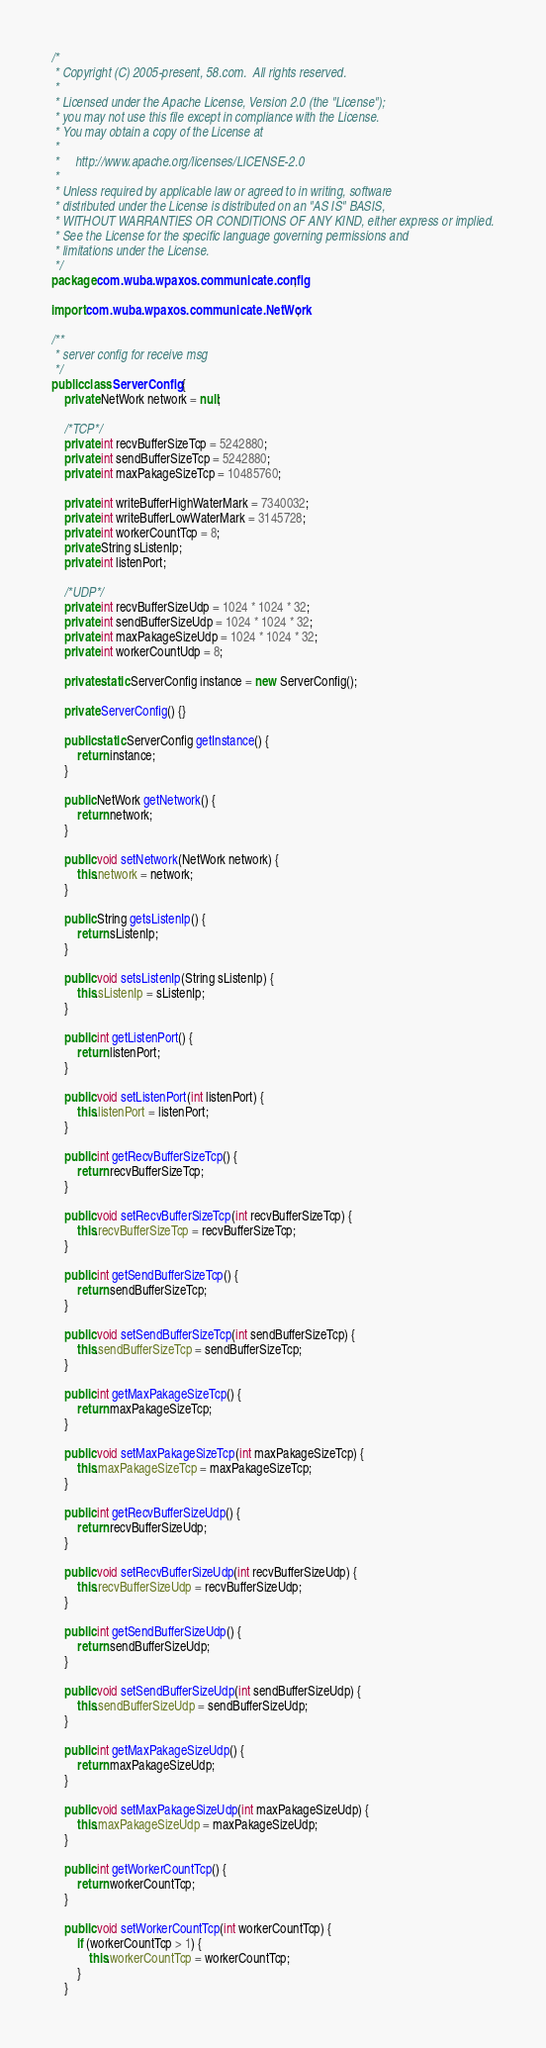Convert code to text. <code><loc_0><loc_0><loc_500><loc_500><_Java_>/*
 * Copyright (C) 2005-present, 58.com.  All rights reserved.
 * 
 * Licensed under the Apache License, Version 2.0 (the "License");
 * you may not use this file except in compliance with the License.
 * You may obtain a copy of the License at
 *
 *     http://www.apache.org/licenses/LICENSE-2.0
 *
 * Unless required by applicable law or agreed to in writing, software
 * distributed under the License is distributed on an "AS IS" BASIS,
 * WITHOUT WARRANTIES OR CONDITIONS OF ANY KIND, either express or implied.
 * See the License for the specific language governing permissions and
 * limitations under the License.
 */
package com.wuba.wpaxos.communicate.config;

import com.wuba.wpaxos.communicate.NetWork;

/**
 * server config for receive msg
 */
public class ServerConfig {
	private NetWork network = null;
	
	/*TCP*/
	private int recvBufferSizeTcp = 5242880;
	private int sendBufferSizeTcp = 5242880;
	private int maxPakageSizeTcp = 10485760;

	private int writeBufferHighWaterMark = 7340032;
	private int writeBufferLowWaterMark = 3145728;
	private int workerCountTcp = 8; 
	private String sListenIp;
	private int listenPort;
	
	/*UDP*/
	private int recvBufferSizeUdp = 1024 * 1024 * 32;
	private int sendBufferSizeUdp = 1024 * 1024 * 32;
	private int maxPakageSizeUdp = 1024 * 1024 * 32;
	private int workerCountUdp = 8;
	
	private static ServerConfig instance = new ServerConfig();
	
	private ServerConfig() {}
	
	public static ServerConfig getInstance() {
		return instance;
	}
	
	public NetWork getNetwork() {
		return network;
	}

	public void setNetwork(NetWork network) {
		this.network = network;
	}

	public String getsListenIp() {
		return sListenIp;
	}

	public void setsListenIp(String sListenIp) {
		this.sListenIp = sListenIp;
	}

	public int getListenPort() {
		return listenPort;
	}

	public void setListenPort(int listenPort) {
		this.listenPort = listenPort;
	}

	public int getRecvBufferSizeTcp() {
		return recvBufferSizeTcp;
	}
	
	public void setRecvBufferSizeTcp(int recvBufferSizeTcp) {
		this.recvBufferSizeTcp = recvBufferSizeTcp;
	}
	
	public int getSendBufferSizeTcp() {
		return sendBufferSizeTcp;
	}
	
	public void setSendBufferSizeTcp(int sendBufferSizeTcp) {
		this.sendBufferSizeTcp = sendBufferSizeTcp;
	}
	
	public int getMaxPakageSizeTcp() {
		return maxPakageSizeTcp;
	}
	
	public void setMaxPakageSizeTcp(int maxPakageSizeTcp) {
		this.maxPakageSizeTcp = maxPakageSizeTcp;
	}
	
	public int getRecvBufferSizeUdp() {
		return recvBufferSizeUdp;
	}
	
	public void setRecvBufferSizeUdp(int recvBufferSizeUdp) {
		this.recvBufferSizeUdp = recvBufferSizeUdp;
	}
	
	public int getSendBufferSizeUdp() {
		return sendBufferSizeUdp;
	}
	
	public void setSendBufferSizeUdp(int sendBufferSizeUdp) {
		this.sendBufferSizeUdp = sendBufferSizeUdp;
	}
	
	public int getMaxPakageSizeUdp() {
		return maxPakageSizeUdp;
	}
	
	public void setMaxPakageSizeUdp(int maxPakageSizeUdp) {
		this.maxPakageSizeUdp = maxPakageSizeUdp;
	}

	public int getWorkerCountTcp() {
		return workerCountTcp;
	}

	public void setWorkerCountTcp(int workerCountTcp) {
		if (workerCountTcp > 1) {
			this.workerCountTcp = workerCountTcp;
		}
	}
</code> 